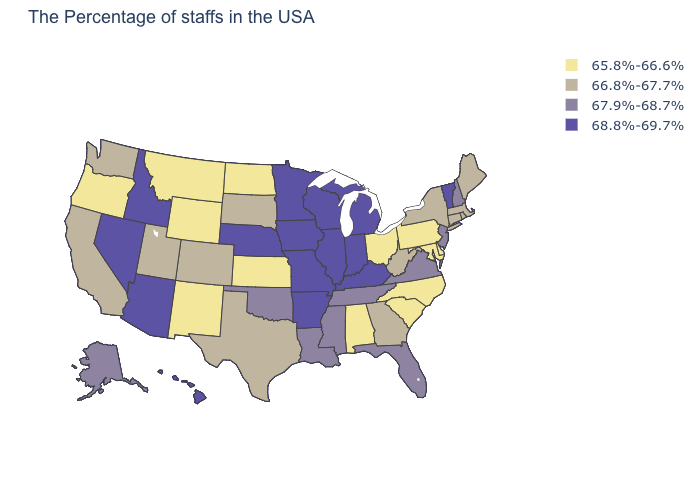What is the value of Alaska?
Write a very short answer. 67.9%-68.7%. What is the value of Rhode Island?
Short answer required. 66.8%-67.7%. What is the value of Montana?
Concise answer only. 65.8%-66.6%. Which states hav the highest value in the Northeast?
Concise answer only. Vermont. What is the value of Ohio?
Answer briefly. 65.8%-66.6%. Which states have the lowest value in the USA?
Be succinct. Delaware, Maryland, Pennsylvania, North Carolina, South Carolina, Ohio, Alabama, Kansas, North Dakota, Wyoming, New Mexico, Montana, Oregon. What is the value of Georgia?
Quick response, please. 66.8%-67.7%. Does Kansas have the highest value in the MidWest?
Concise answer only. No. What is the highest value in the West ?
Give a very brief answer. 68.8%-69.7%. Among the states that border New Mexico , does Arizona have the highest value?
Be succinct. Yes. Which states have the lowest value in the USA?
Concise answer only. Delaware, Maryland, Pennsylvania, North Carolina, South Carolina, Ohio, Alabama, Kansas, North Dakota, Wyoming, New Mexico, Montana, Oregon. What is the value of South Dakota?
Give a very brief answer. 66.8%-67.7%. Does Wisconsin have a higher value than Alabama?
Concise answer only. Yes. What is the highest value in the USA?
Be succinct. 68.8%-69.7%. Does Ohio have the highest value in the MidWest?
Concise answer only. No. 